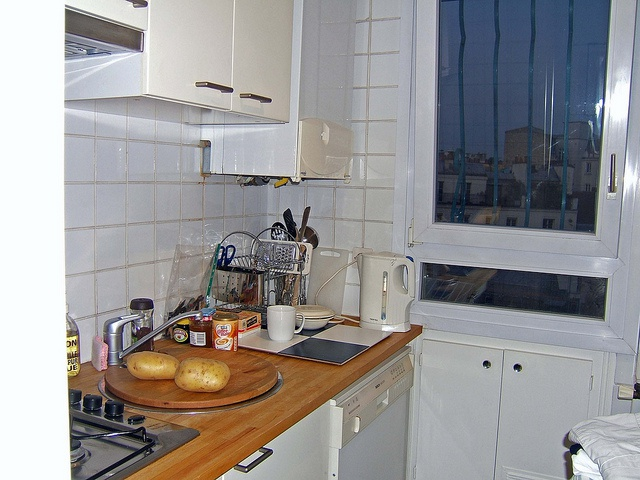Describe the objects in this image and their specific colors. I can see sink in white, brown, maroon, and gray tones, oven in white, gray, and lightgray tones, oven in white, gray, black, and maroon tones, cup in white, darkgray, lightgray, and gray tones, and bottle in white, gray, darkgray, khaki, and olive tones in this image. 